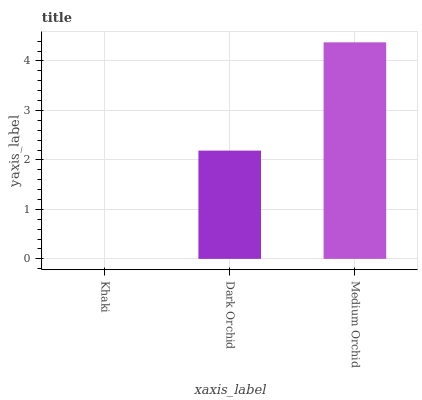Is Khaki the minimum?
Answer yes or no. Yes. Is Medium Orchid the maximum?
Answer yes or no. Yes. Is Dark Orchid the minimum?
Answer yes or no. No. Is Dark Orchid the maximum?
Answer yes or no. No. Is Dark Orchid greater than Khaki?
Answer yes or no. Yes. Is Khaki less than Dark Orchid?
Answer yes or no. Yes. Is Khaki greater than Dark Orchid?
Answer yes or no. No. Is Dark Orchid less than Khaki?
Answer yes or no. No. Is Dark Orchid the high median?
Answer yes or no. Yes. Is Dark Orchid the low median?
Answer yes or no. Yes. Is Medium Orchid the high median?
Answer yes or no. No. Is Khaki the low median?
Answer yes or no. No. 